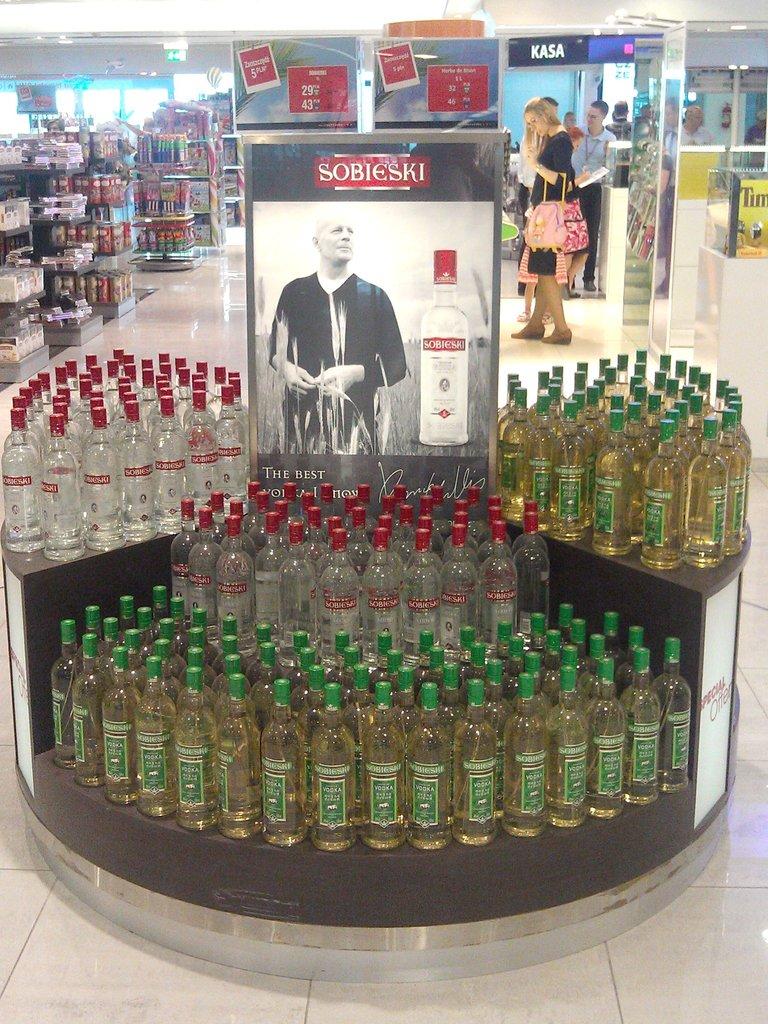What is the name above the man in the poster?
Your response must be concise. Sobieski. What brand are these alcohol?
Your answer should be very brief. Sobieski. 